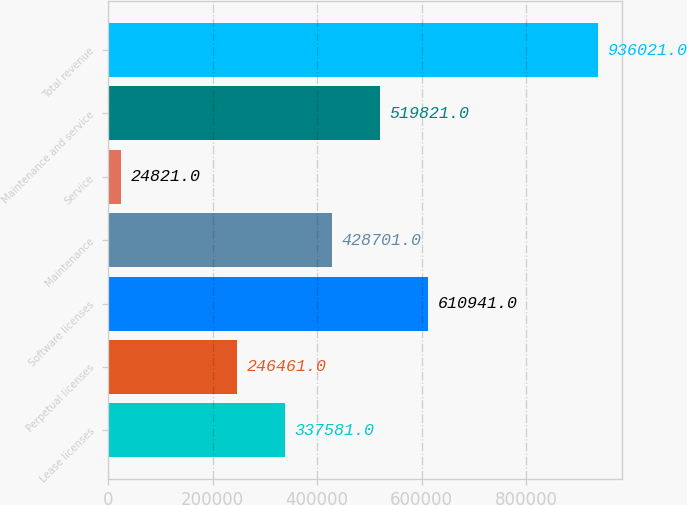Convert chart to OTSL. <chart><loc_0><loc_0><loc_500><loc_500><bar_chart><fcel>Lease licenses<fcel>Perpetual licenses<fcel>Software licenses<fcel>Maintenance<fcel>Service<fcel>Maintenance and service<fcel>Total revenue<nl><fcel>337581<fcel>246461<fcel>610941<fcel>428701<fcel>24821<fcel>519821<fcel>936021<nl></chart> 